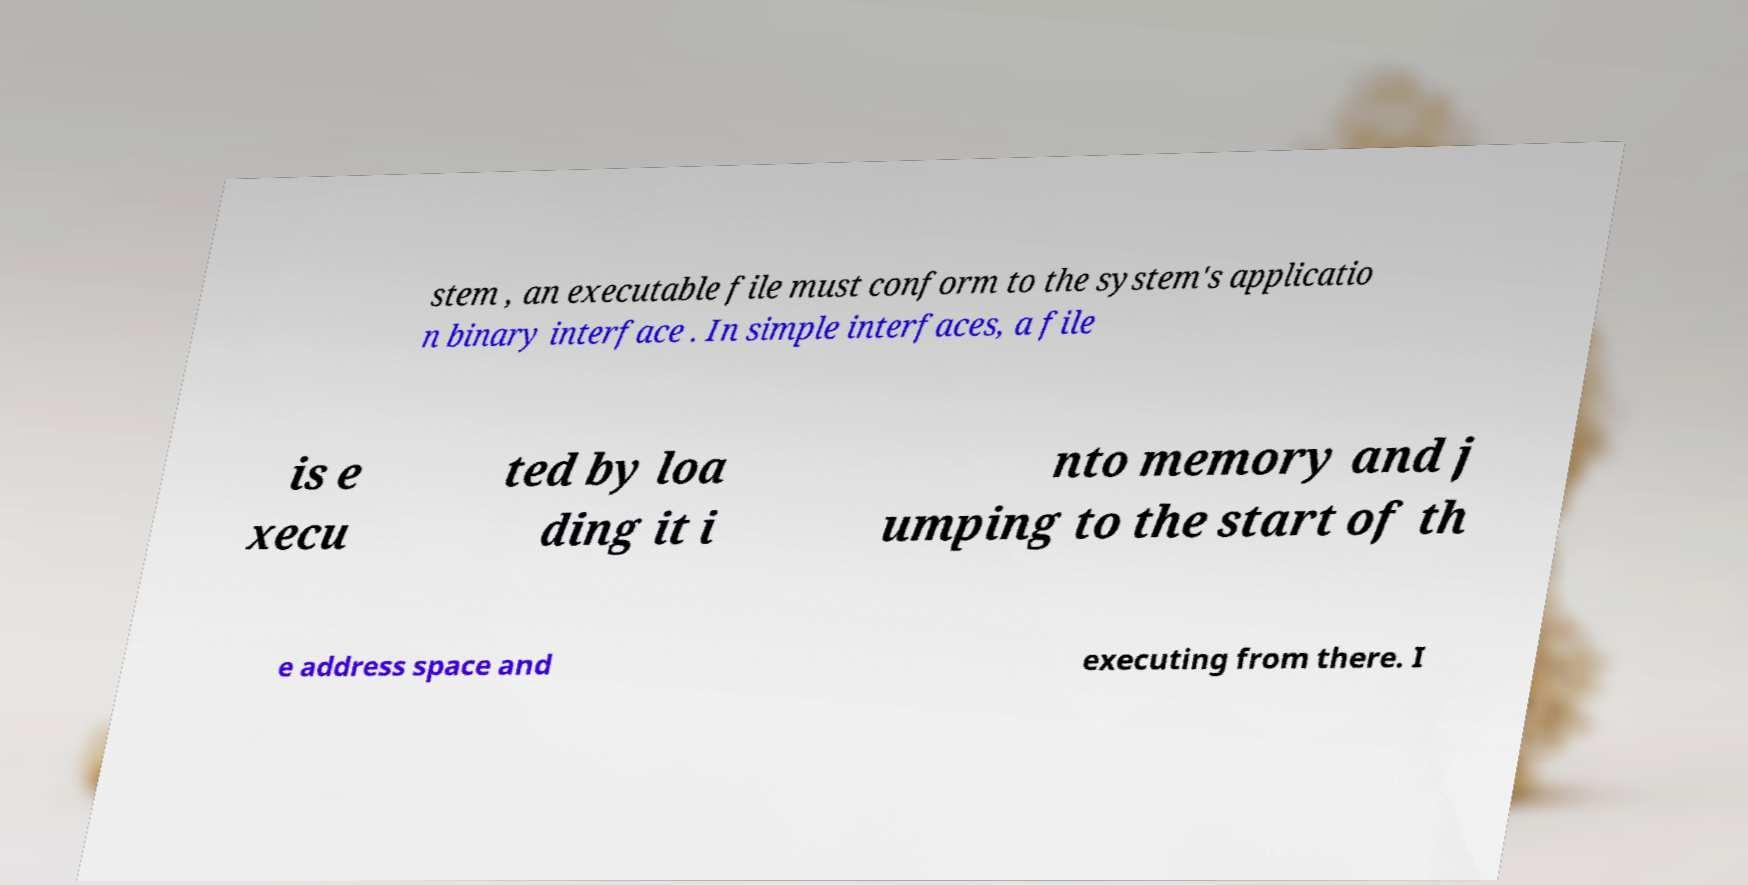Could you assist in decoding the text presented in this image and type it out clearly? stem , an executable file must conform to the system's applicatio n binary interface . In simple interfaces, a file is e xecu ted by loa ding it i nto memory and j umping to the start of th e address space and executing from there. I 